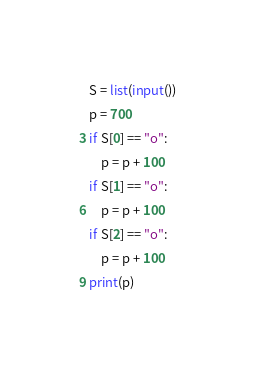Convert code to text. <code><loc_0><loc_0><loc_500><loc_500><_Python_>S = list(input())
p = 700
if S[0] == "o":
    p = p + 100
if S[1] == "o":
    p = p + 100
if S[2] == "o":
    p = p + 100
print(p)</code> 